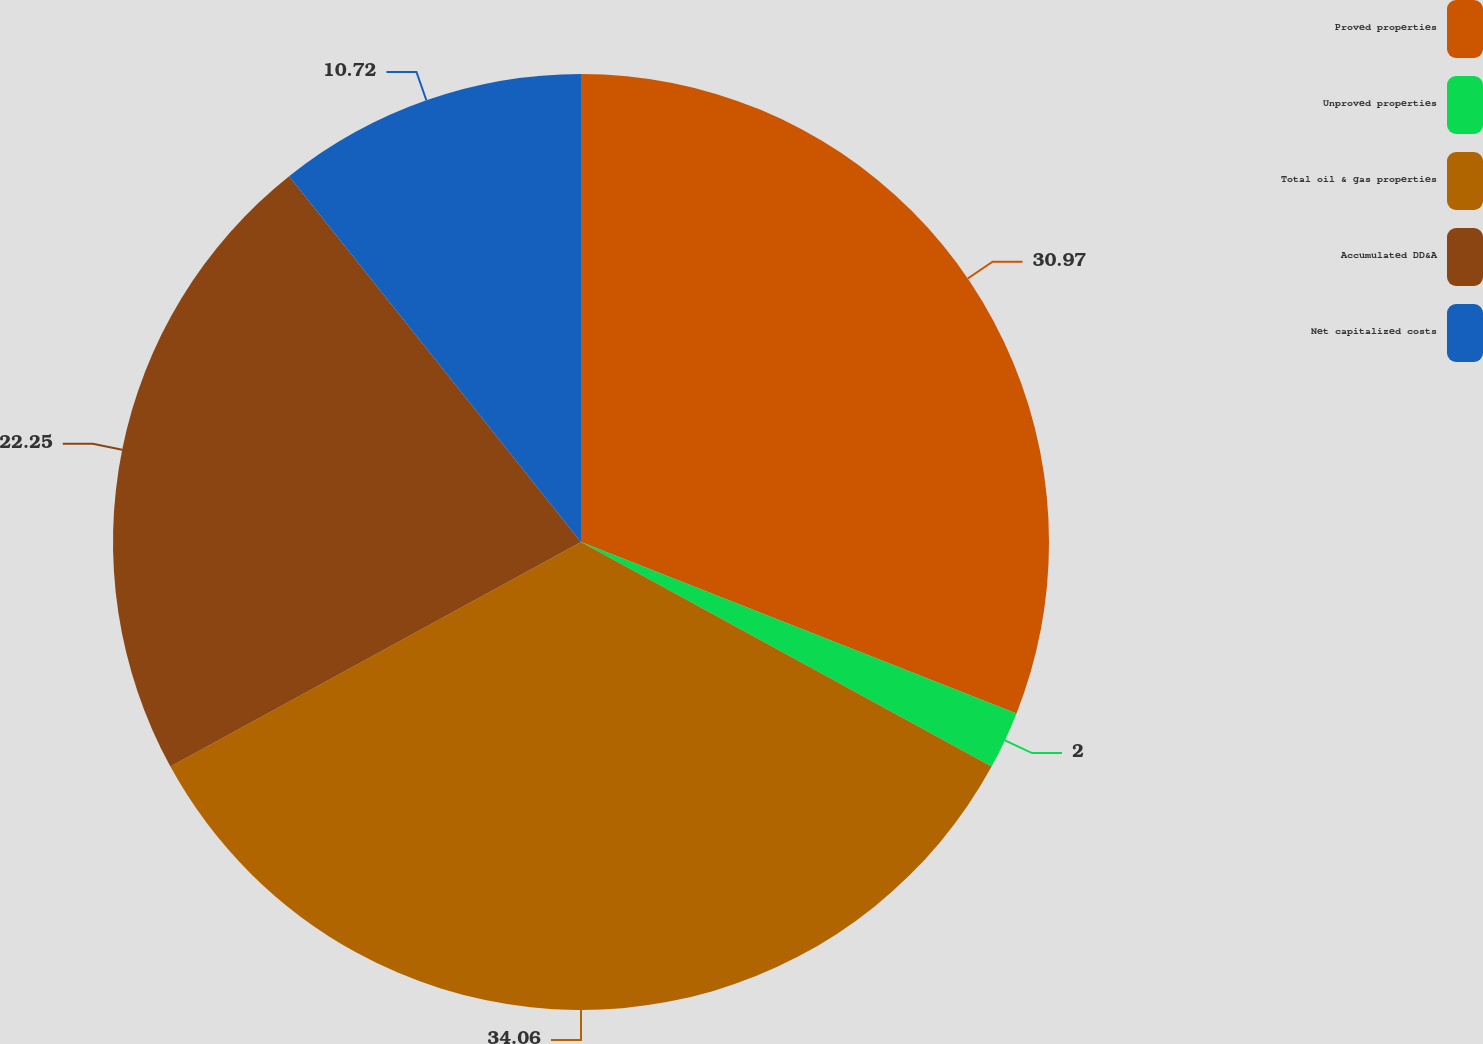Convert chart. <chart><loc_0><loc_0><loc_500><loc_500><pie_chart><fcel>Proved properties<fcel>Unproved properties<fcel>Total oil & gas properties<fcel>Accumulated DD&A<fcel>Net capitalized costs<nl><fcel>30.97%<fcel>2.0%<fcel>34.07%<fcel>22.25%<fcel>10.72%<nl></chart> 